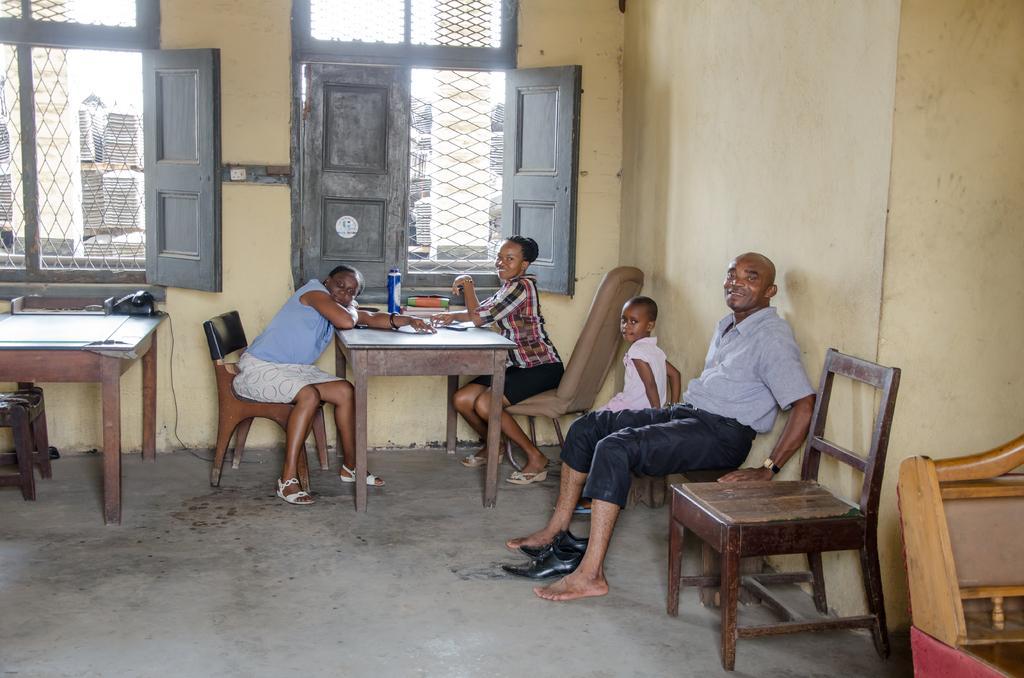Can you describe this image briefly? To the left side of the picture there is a table. To left corner of the table there is a telephone. In front of table there are two ladies sitting. In between them there is a table with bottle on it. And to the right side there is a wooden chair. Beside the chair there is a man with blue shirt and pant sitting on the bench. In between his legs there are shoes. Beside him there is a girl sitting. In the middle of the picture there are two windows. 